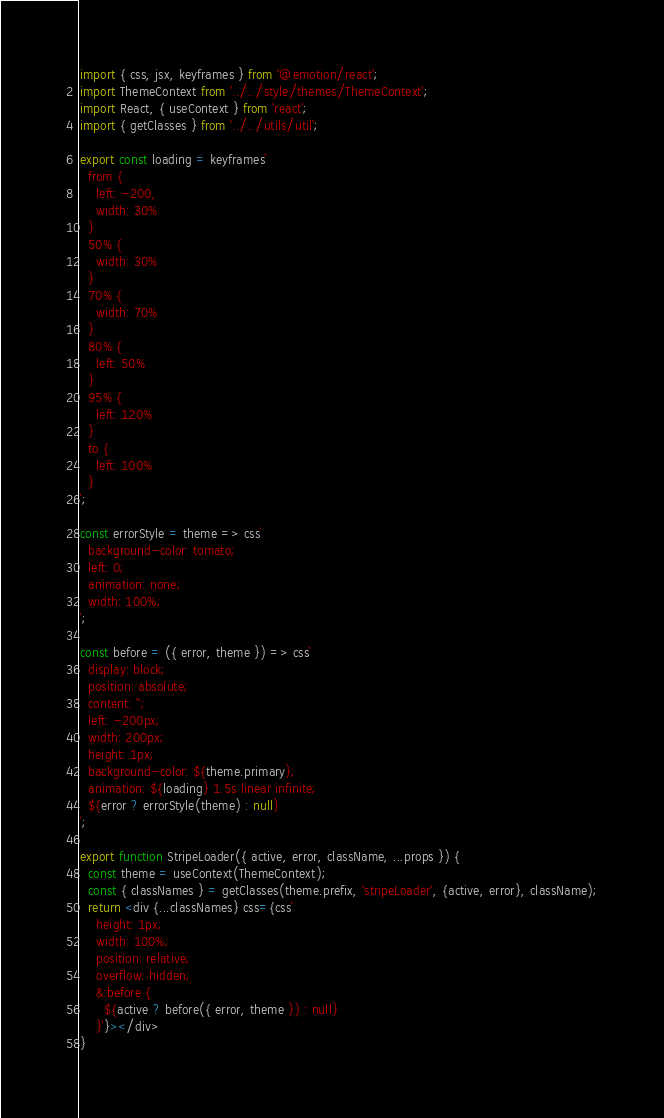Convert code to text. <code><loc_0><loc_0><loc_500><loc_500><_JavaScript_>
import { css, jsx, keyframes } from '@emotion/react';
import ThemeContext from '../../style/themes/ThemeContext';
import React, { useContext } from 'react';
import { getClasses } from '../../utils/util';

export const loading = keyframes`
  from {
    left: -200,
    width: 30% 
  }
  50% {
    width: 30%
  }
  70% {
    width: 70%
  }
  80% {
    left: 50%
  }
  95% {
    left: 120%
  }
  to {
    left: 100%
  }
`;

const errorStyle = theme => css`
  background-color: tomato;
  left: 0;
  animation: none;
  width: 100%;
`;

const before = ({ error, theme }) => css`
  display: block;
  position: absolute;
  content: '';
  left: -200px;
  width: 200px;
  height: 1px;
  background-color: ${theme.primary};
  animation: ${loading} 1.5s linear infinite;
  ${error ? errorStyle(theme) : null}
`;

export function StripeLoader({ active, error, className, ...props }) {
  const theme = useContext(ThemeContext);
  const { classNames } = getClasses(theme.prefix, 'stripeLoader', {active, error}, className);
  return <div {...classNames} css={css`
    height: 1px;
    width: 100%;
    position: relative;
    overflow: hidden;
    &:before {
      ${active ? before({ error, theme }) : null}
    }`}></div>
}</code> 